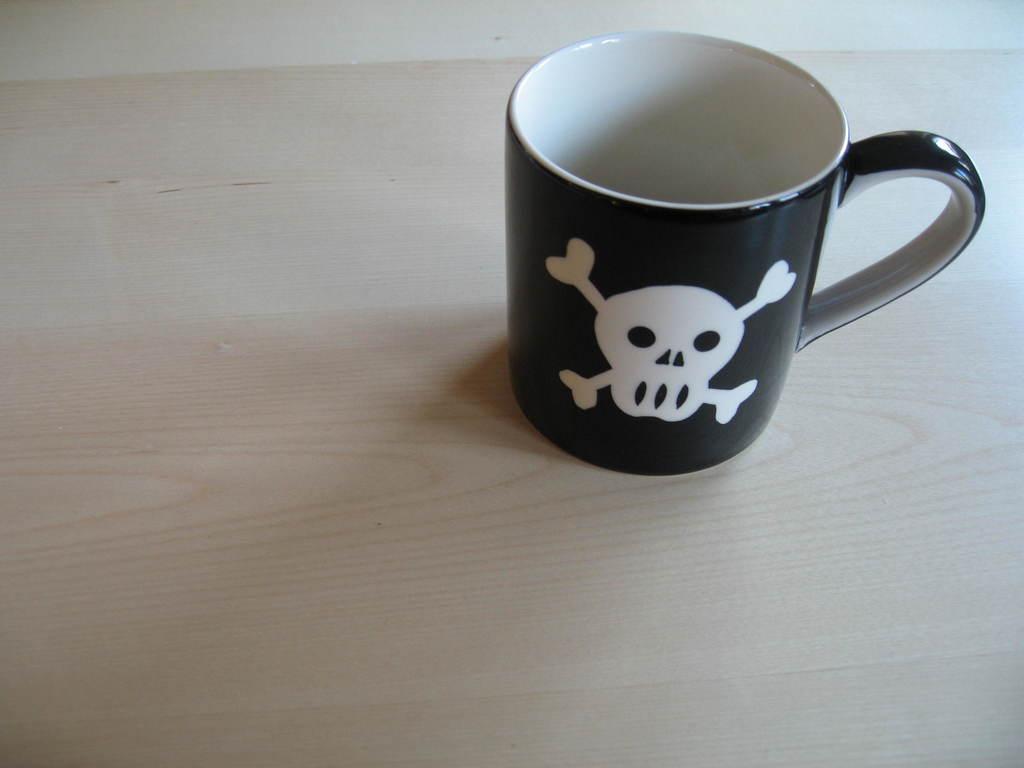Please provide a concise description of this image. In this picture we can see a cup and we can see a painting on the cup. 